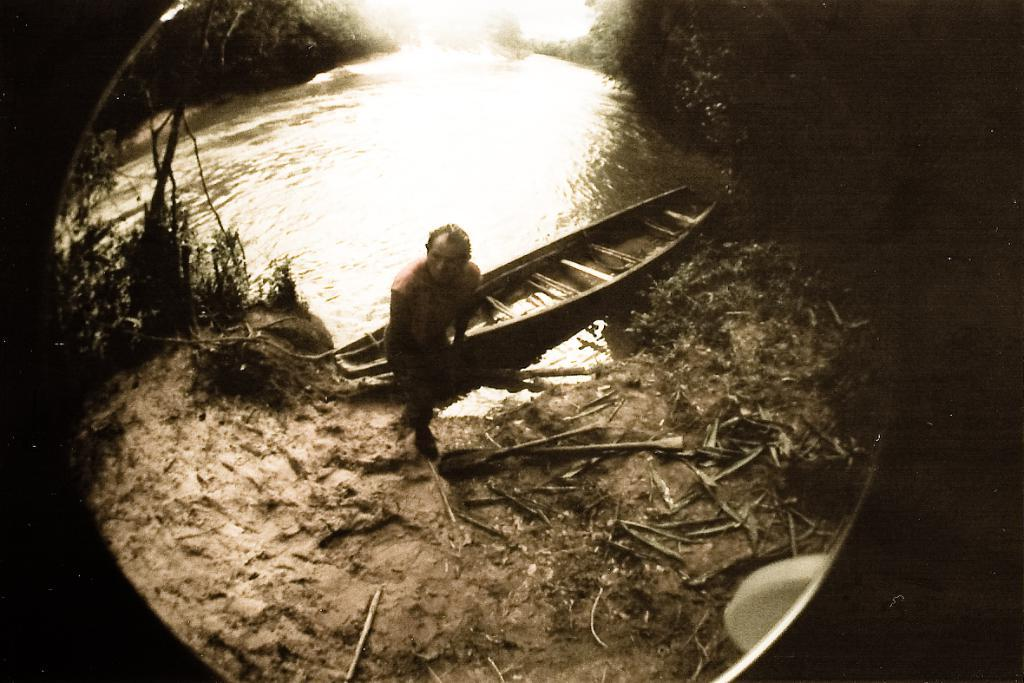What type of water body is present in the image? There is a river in the image. What is floating on the river in the image? There is a boat in the image. Can you describe the person in the image? There is a person standing on the ground in the image. What type of vegetation is visible in the image? There are trees in the image. What type of dock can be seen in the image? There is no dock present in the image. What nation is the person in the image from? The image does not provide any information about the person's nationality. 